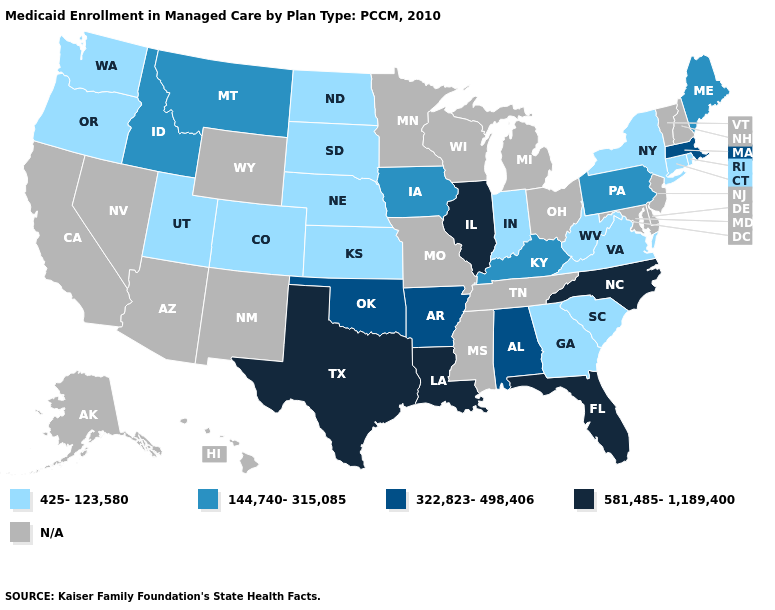What is the value of Georgia?
Answer briefly. 425-123,580. Is the legend a continuous bar?
Concise answer only. No. Does the first symbol in the legend represent the smallest category?
Give a very brief answer. Yes. Name the states that have a value in the range 144,740-315,085?
Concise answer only. Idaho, Iowa, Kentucky, Maine, Montana, Pennsylvania. What is the lowest value in the USA?
Concise answer only. 425-123,580. What is the highest value in the Northeast ?
Short answer required. 322,823-498,406. Name the states that have a value in the range 581,485-1,189,400?
Give a very brief answer. Florida, Illinois, Louisiana, North Carolina, Texas. Is the legend a continuous bar?
Concise answer only. No. Name the states that have a value in the range 425-123,580?
Quick response, please. Colorado, Connecticut, Georgia, Indiana, Kansas, Nebraska, New York, North Dakota, Oregon, Rhode Island, South Carolina, South Dakota, Utah, Virginia, Washington, West Virginia. Does the map have missing data?
Answer briefly. Yes. Does West Virginia have the lowest value in the South?
Write a very short answer. Yes. Among the states that border Utah , which have the highest value?
Give a very brief answer. Idaho. 